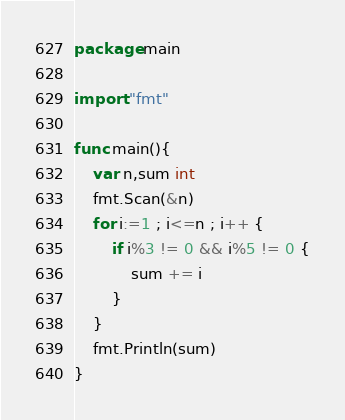Convert code to text. <code><loc_0><loc_0><loc_500><loc_500><_Go_>package main

import "fmt"

func main(){
	var n,sum int
	fmt.Scan(&n)
	for i:=1 ; i<=n ; i++ {
		if i%3 != 0 && i%5 != 0 {
			sum += i
		}
	}
	fmt.Println(sum)
}
</code> 